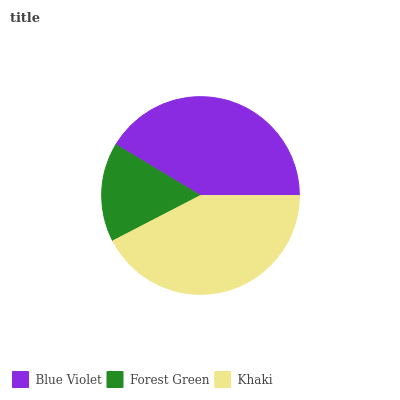Is Forest Green the minimum?
Answer yes or no. Yes. Is Khaki the maximum?
Answer yes or no. Yes. Is Khaki the minimum?
Answer yes or no. No. Is Forest Green the maximum?
Answer yes or no. No. Is Khaki greater than Forest Green?
Answer yes or no. Yes. Is Forest Green less than Khaki?
Answer yes or no. Yes. Is Forest Green greater than Khaki?
Answer yes or no. No. Is Khaki less than Forest Green?
Answer yes or no. No. Is Blue Violet the high median?
Answer yes or no. Yes. Is Blue Violet the low median?
Answer yes or no. Yes. Is Khaki the high median?
Answer yes or no. No. Is Forest Green the low median?
Answer yes or no. No. 